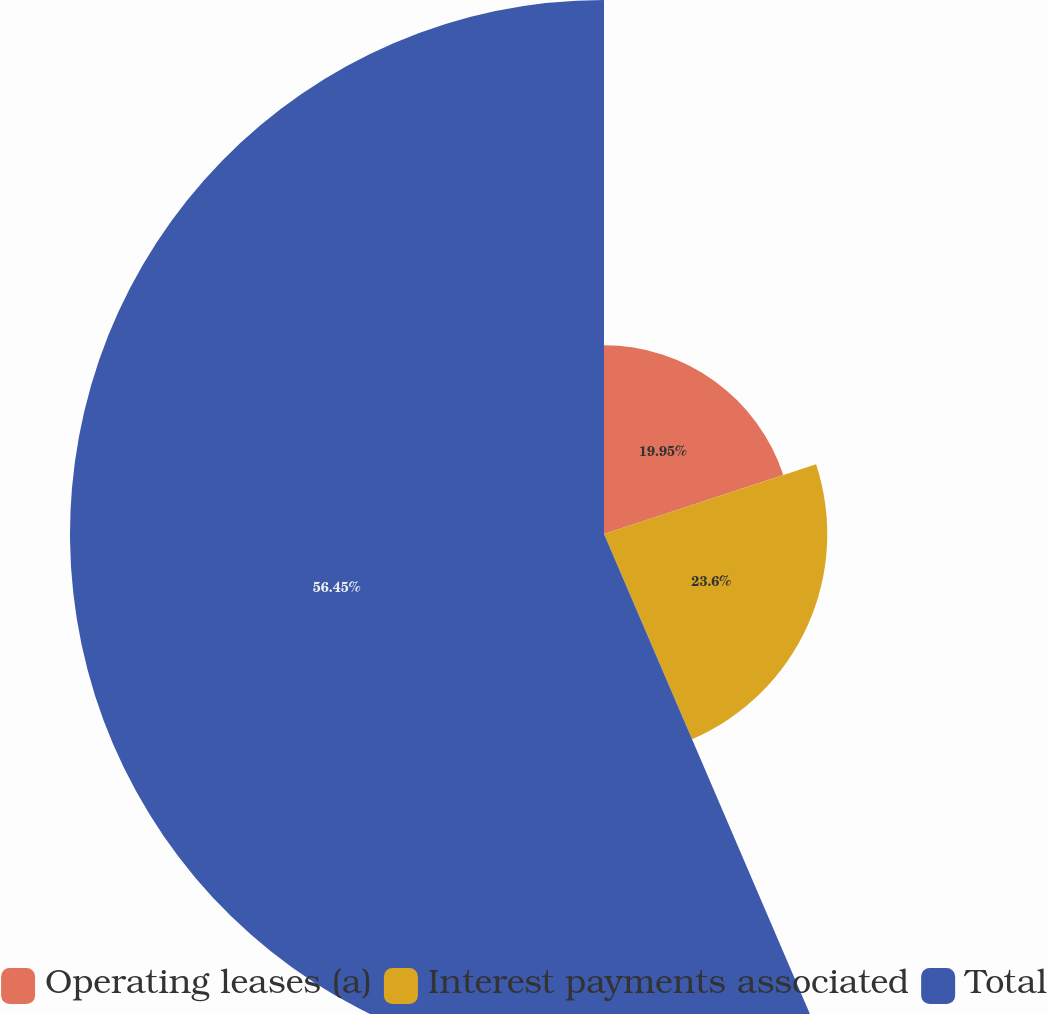<chart> <loc_0><loc_0><loc_500><loc_500><pie_chart><fcel>Operating leases (a)<fcel>Interest payments associated<fcel>Total<nl><fcel>19.95%<fcel>23.6%<fcel>56.45%<nl></chart> 